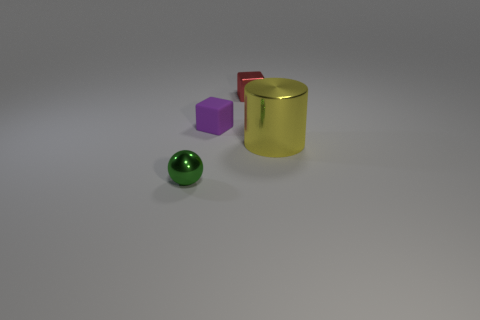Is there any other thing that has the same material as the small purple block?
Keep it short and to the point. No. How many big gray matte things are there?
Offer a terse response. 0. How many cylinders are the same size as the purple block?
Provide a short and direct response. 0. What is the material of the big yellow object?
Your response must be concise. Metal. Is there anything else that has the same size as the yellow cylinder?
Your response must be concise. No. There is a thing that is left of the red thing and in front of the purple rubber cube; what is its size?
Your answer should be very brief. Small. What is the shape of the green object that is the same material as the big yellow cylinder?
Your response must be concise. Sphere. Does the red thing have the same material as the tiny block to the left of the metallic block?
Offer a terse response. No. Are there any yellow cylinders that are on the left side of the small thing that is on the right side of the purple rubber thing?
Keep it short and to the point. No. What is the material of the tiny purple object that is the same shape as the red object?
Offer a terse response. Rubber. 